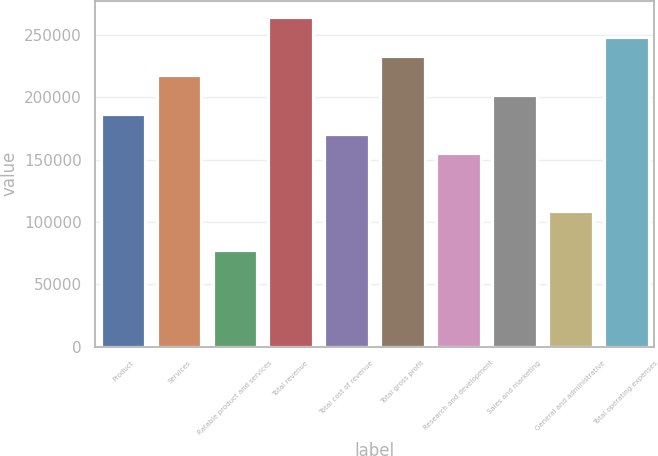Convert chart. <chart><loc_0><loc_0><loc_500><loc_500><bar_chart><fcel>Product<fcel>Services<fcel>Ratable product and services<fcel>Total revenue<fcel>Total cost of revenue<fcel>Total gross profit<fcel>Research and development<fcel>Sales and marketing<fcel>General and administrative<fcel>Total operating expenses<nl><fcel>186439<fcel>217512<fcel>77683.6<fcel>264121<fcel>170903<fcel>233048<fcel>155366<fcel>201976<fcel>108757<fcel>248585<nl></chart> 